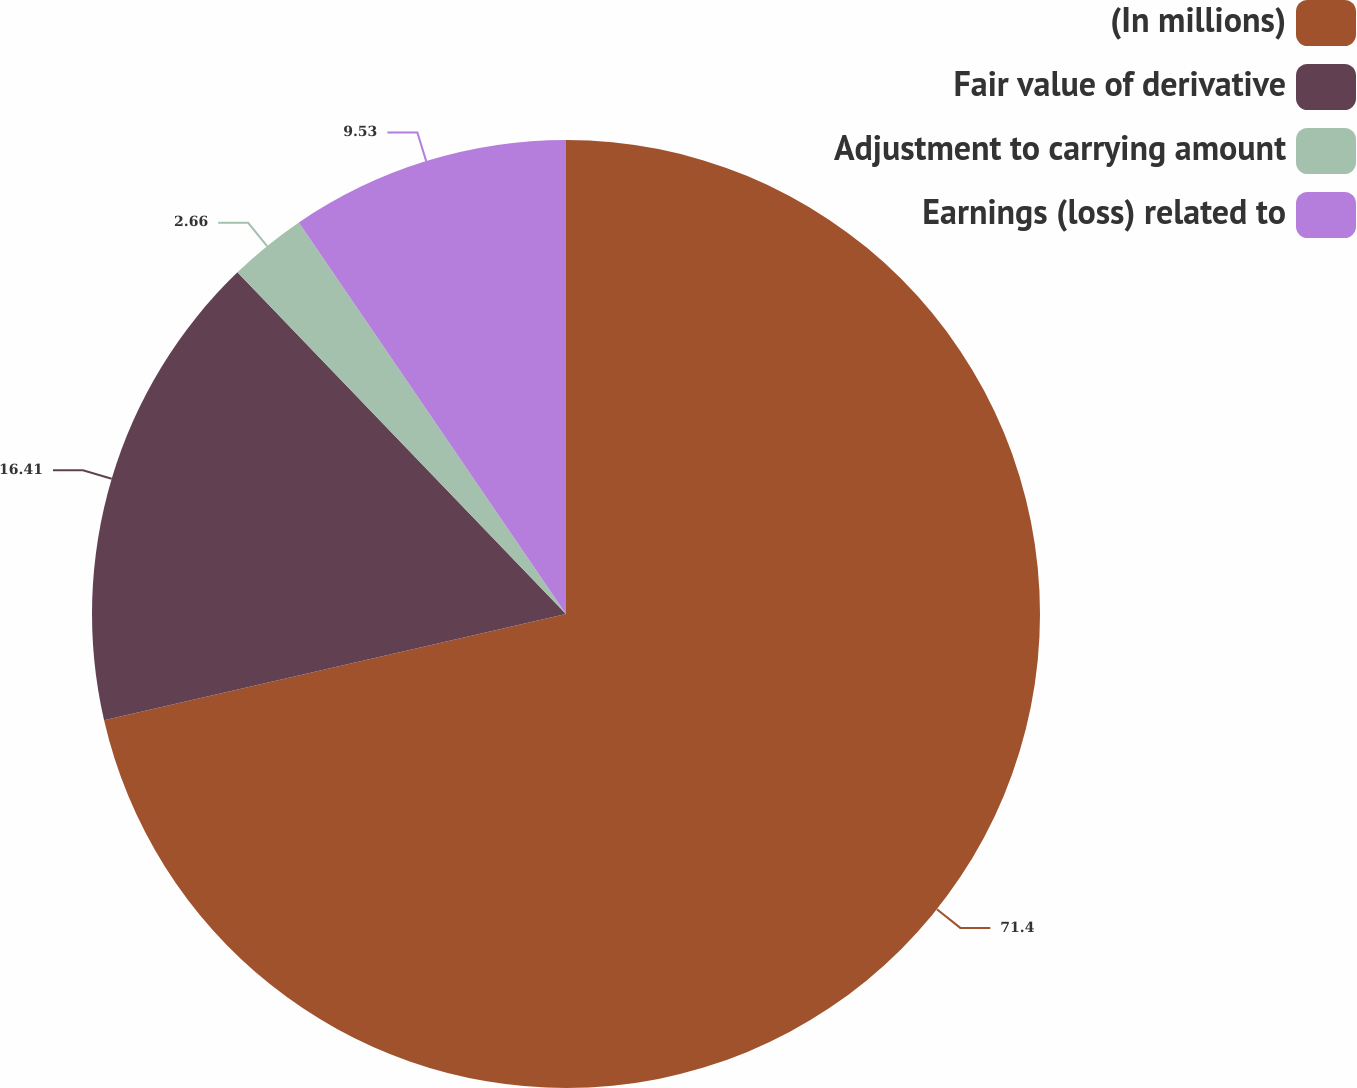Convert chart to OTSL. <chart><loc_0><loc_0><loc_500><loc_500><pie_chart><fcel>(In millions)<fcel>Fair value of derivative<fcel>Adjustment to carrying amount<fcel>Earnings (loss) related to<nl><fcel>71.4%<fcel>16.41%<fcel>2.66%<fcel>9.53%<nl></chart> 